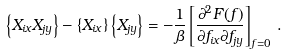Convert formula to latex. <formula><loc_0><loc_0><loc_500><loc_500>\left \{ X _ { i x } X _ { j y } \right \} - \left \{ X _ { i x } \right \} \left \{ X _ { j y } \right \} = - \frac { 1 } { \beta } \left [ \frac { \partial ^ { 2 } F ( f ) } { { \partial f _ { i x } } { \partial f _ { j y } } } \right ] _ { f = 0 } \, .</formula> 